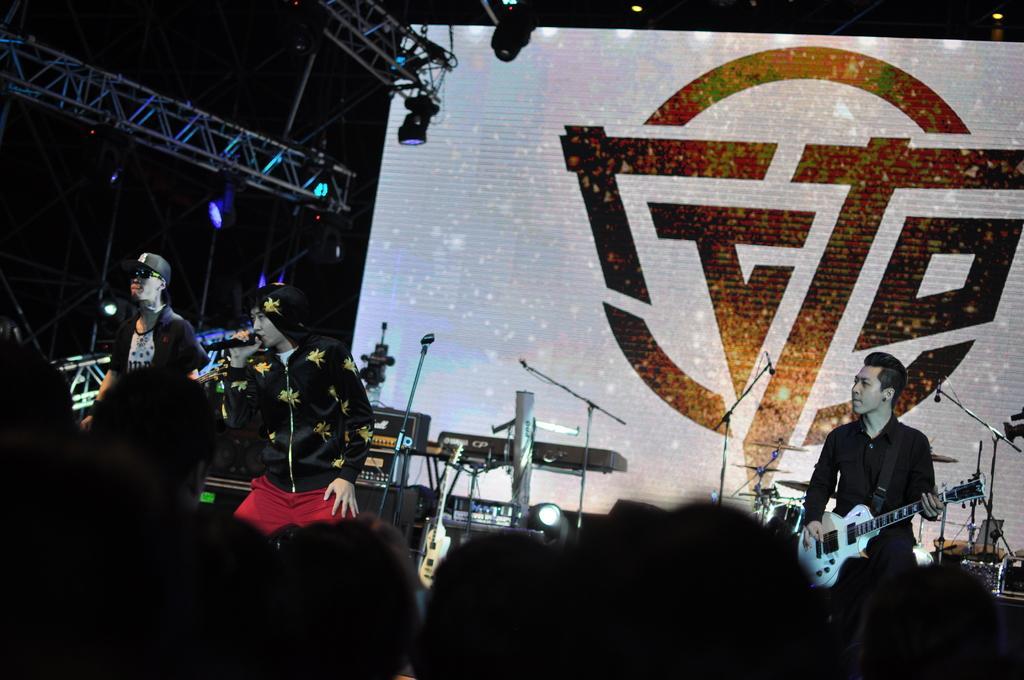In one or two sentences, can you explain what this image depicts? In this image, we can see few people. Here a person is holding a microphone. On the right side person is playing a guitar. At the bottom of the image, we can see a group of people heads. Background we can see banner, lights, rods and few instruments. 